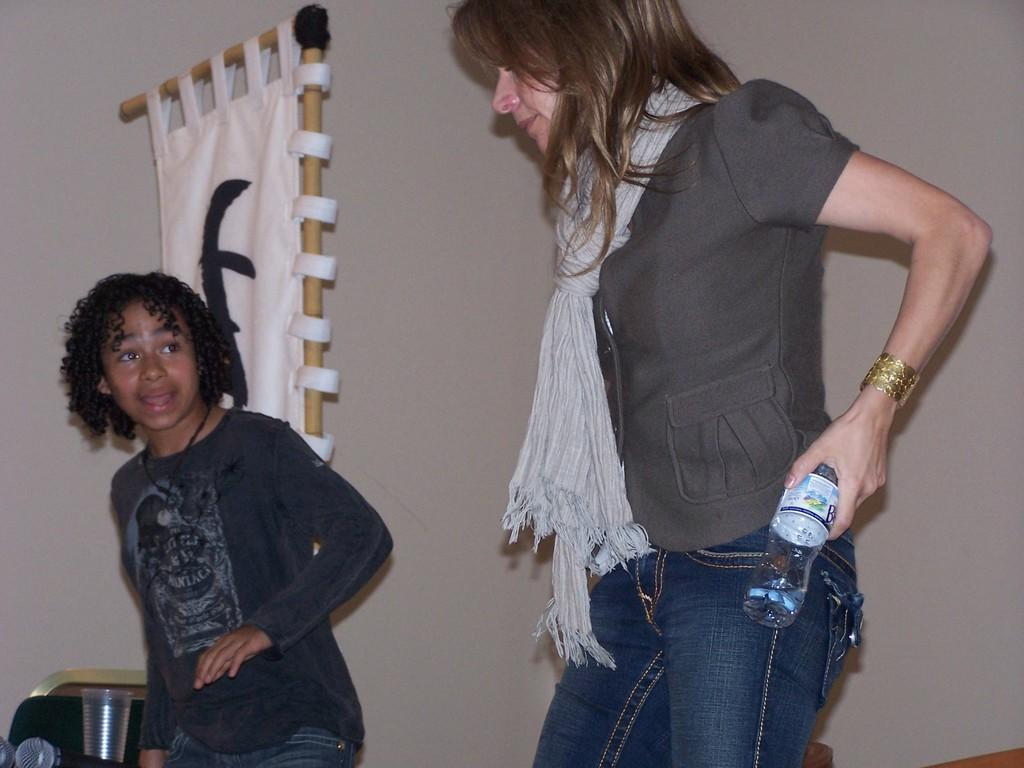Who are the people in the image? There is a woman and a boy in the image. What are they doing? They are dancing. What is the woman holding? The woman is holding a bottle. What can be seen in the background of the image? There is a wall in the background of the image, and a frame is fixed on the wall. What is located to the left of the image? There is a glass to the left of the image. What type of pancake is the boy flipping in the image? There is no pancake present in the image; the boy is dancing with the woman. How many feet does the woman have in the image? The woman has two feet in the image, as is typical for humans. 